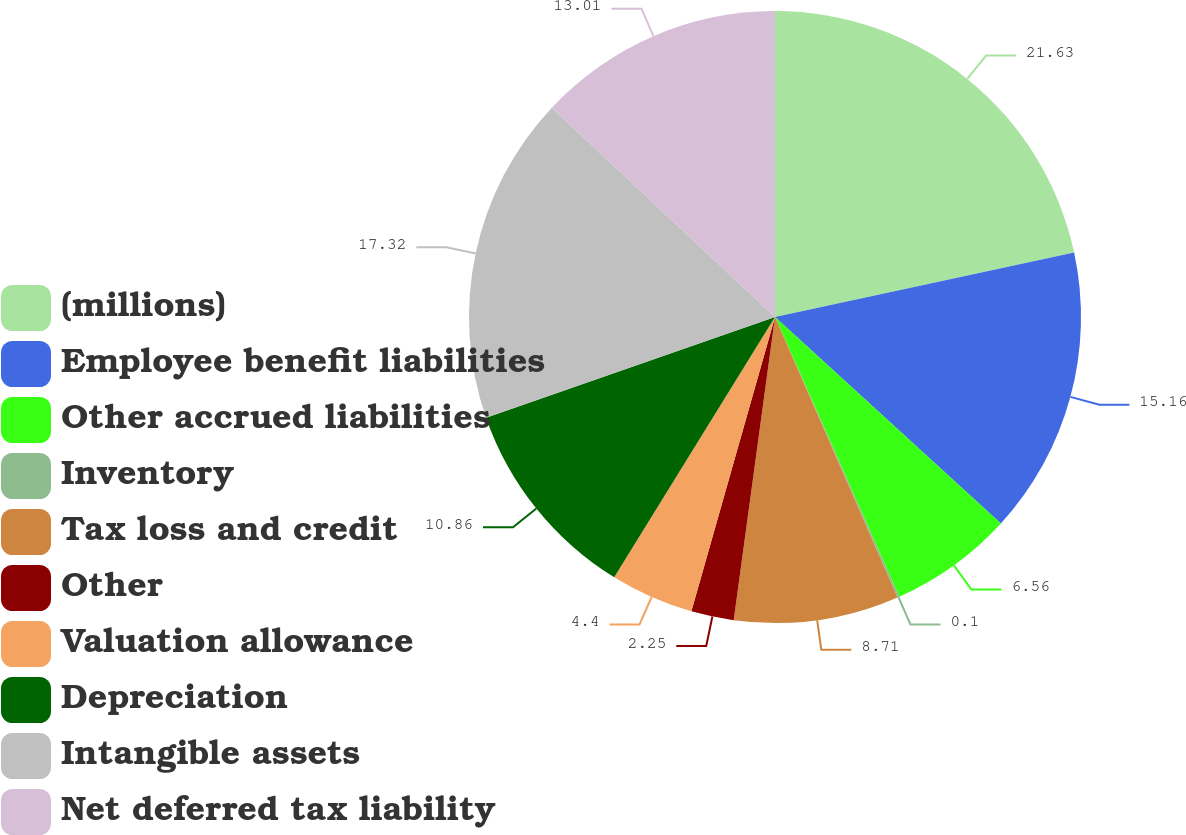<chart> <loc_0><loc_0><loc_500><loc_500><pie_chart><fcel>(millions)<fcel>Employee benefit liabilities<fcel>Other accrued liabilities<fcel>Inventory<fcel>Tax loss and credit<fcel>Other<fcel>Valuation allowance<fcel>Depreciation<fcel>Intangible assets<fcel>Net deferred tax liability<nl><fcel>21.62%<fcel>15.16%<fcel>6.56%<fcel>0.1%<fcel>8.71%<fcel>2.25%<fcel>4.4%<fcel>10.86%<fcel>17.32%<fcel>13.01%<nl></chart> 